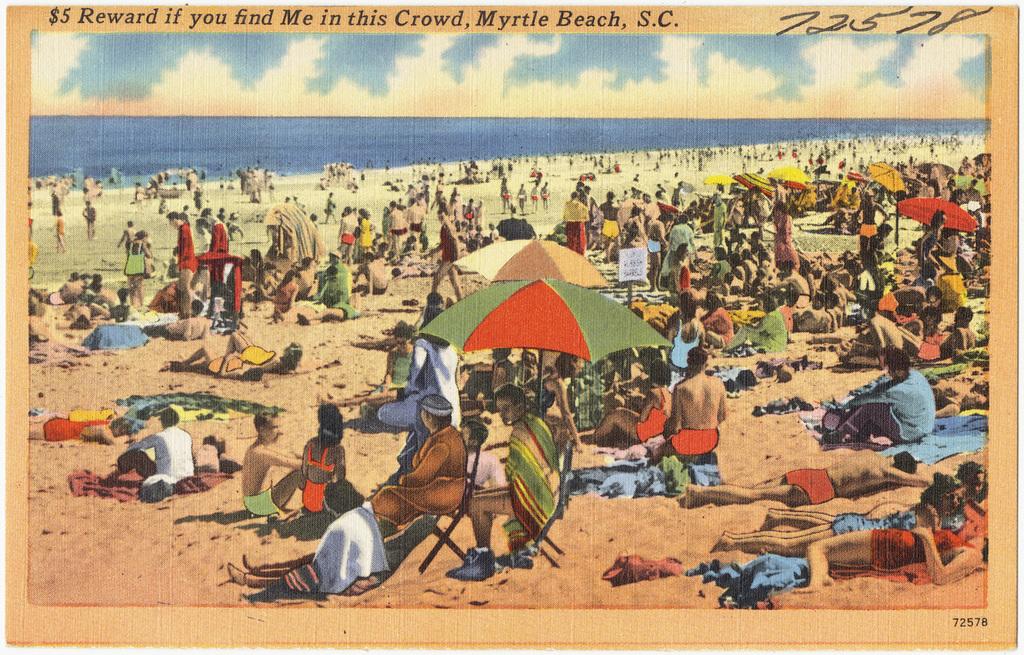What is the reward for finding the person in the crowd?
Your answer should be compact. $5. What city is this card from?
Keep it short and to the point. Myrtle beach. 